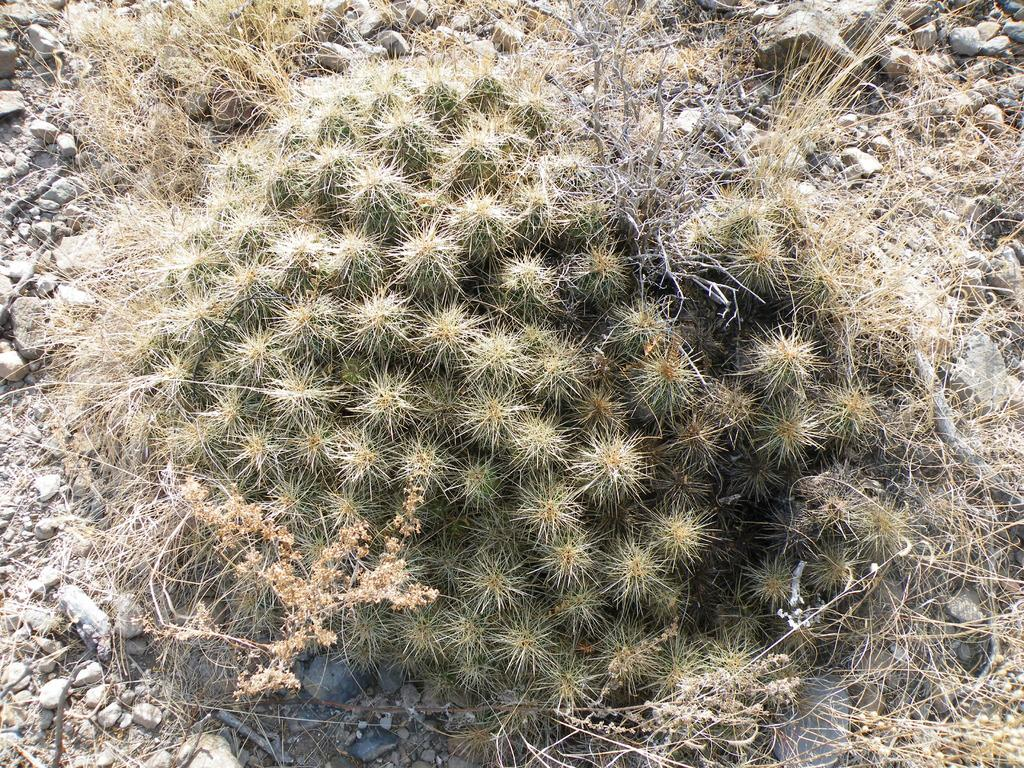What type of surface is visible on the ground in the image? There is grass and stones on the ground in the image. Can you describe the texture of the grass in the image? The texture of the grass cannot be determined from the image alone, but it is likely to be soft and natural. How many types of surfaces are present on the ground in the image? There are two types of surfaces present on the ground in the image: grass and stones. What type of button can be seen on the apple in the image? There is no button or apple present in the image; it only features grass and stones on the ground. 